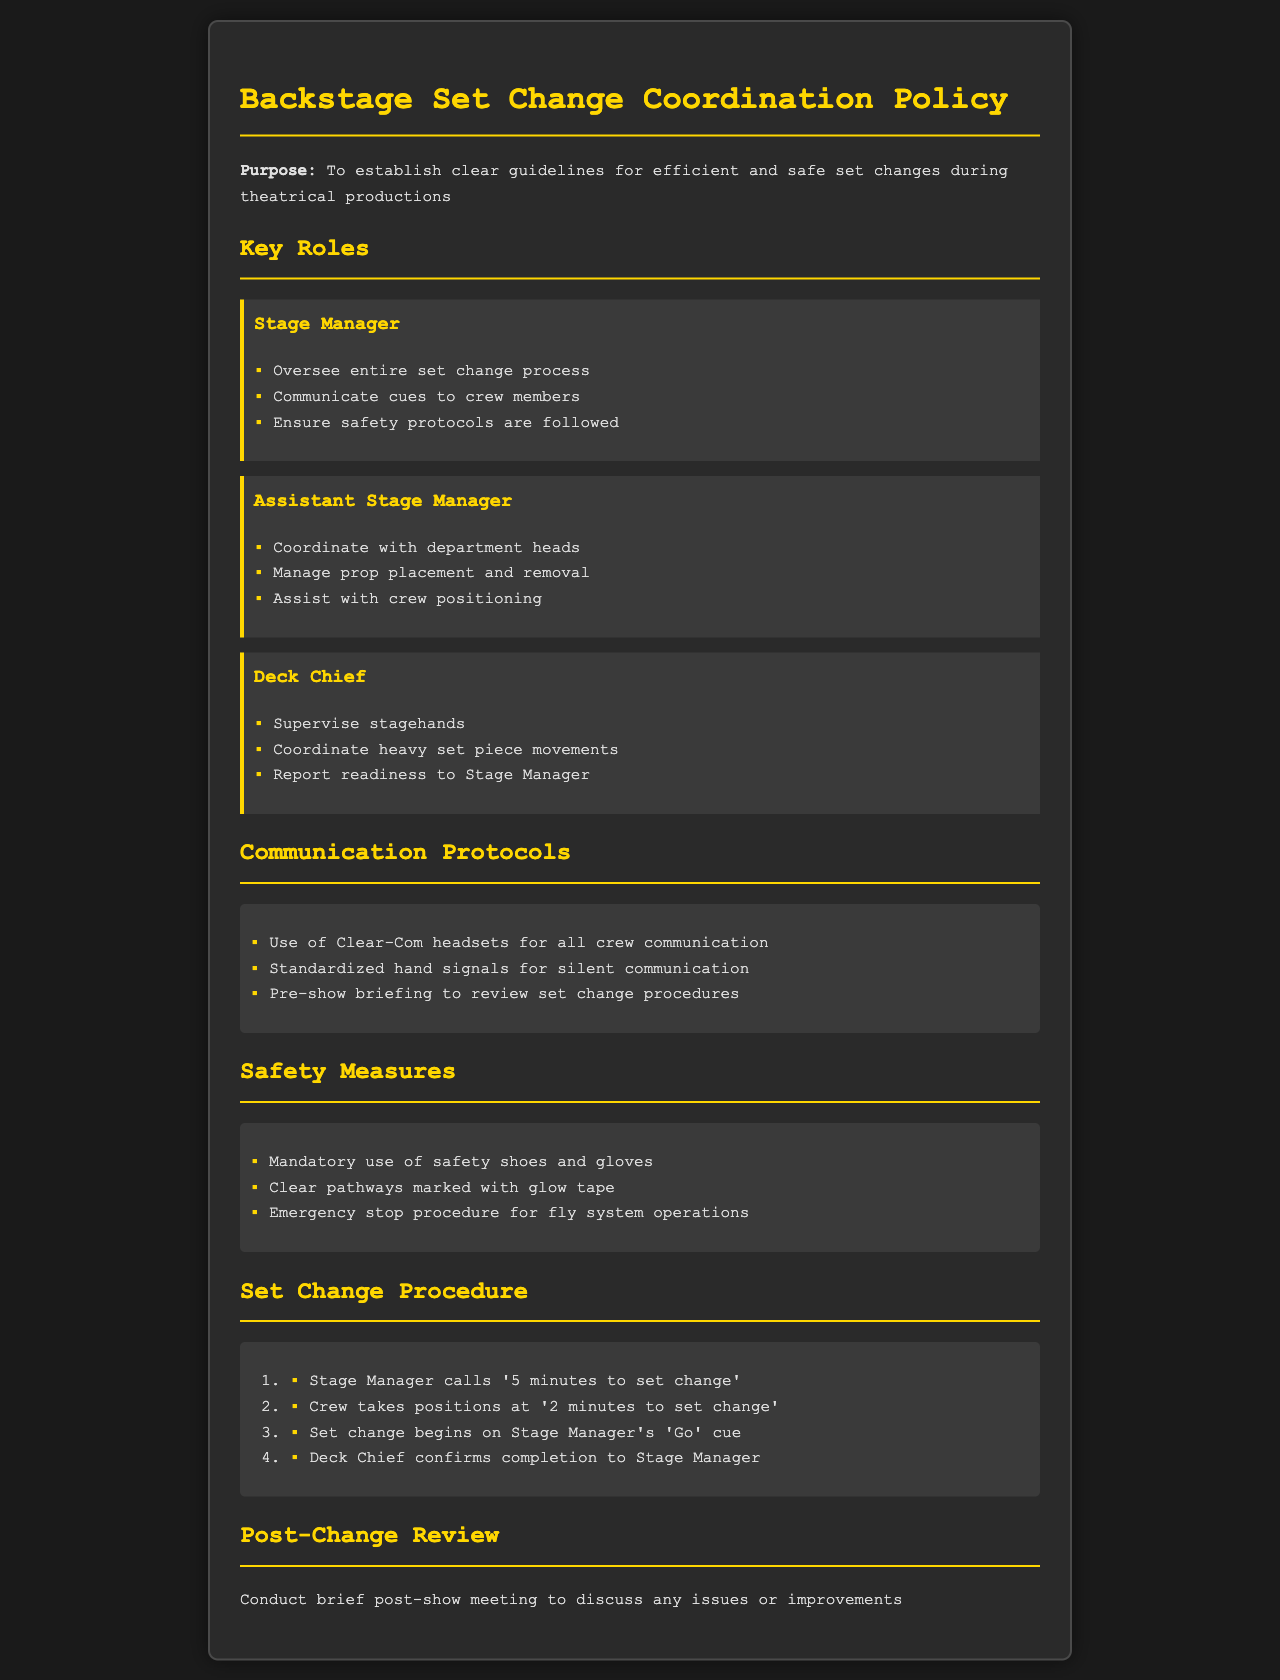What is the purpose of the document? The purpose is stated at the beginning of the document, outlining the need for clear guidelines for set changes.
Answer: To establish clear guidelines for efficient and safe set changes during theatrical productions Who oversees the entire set change process? The document specifies this role under the Key Roles section.
Answer: Stage Manager What communication method is required for all crew members? The Communication Protocols section states the required communication method.
Answer: Clear-Com headsets What must crew members wear for safety? The Safety Measures section lists mandatory safety gear.
Answer: Safety shoes and gloves When does the set change begin? The Set Change Procedure outlines when the change initiates based on the Stage Manager's cue.
Answer: On Stage Manager's 'Go' cue Which role manages prop placement and removal? The document identifies this responsibility under the Assistant Stage Manager’s description.
Answer: Assistant Stage Manager What should be discussed in the post-change review? The document indicates the focus of the post-show meeting under Post-Change Review section.
Answer: Any issues or improvements How many minutes before does the Stage Manager call for a set change? The Set Change Procedure specifies this time frame as part of the preparation process.
Answer: 5 minutes 